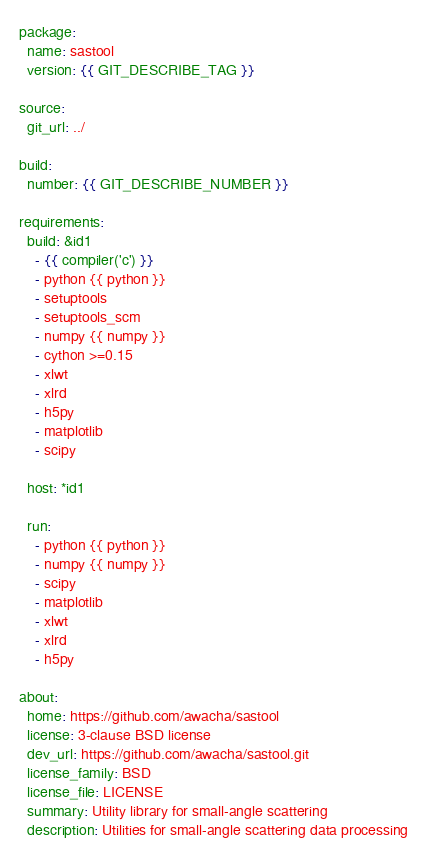<code> <loc_0><loc_0><loc_500><loc_500><_YAML_>package:
  name: sastool
  version: {{ GIT_DESCRIBE_TAG }}

source:
  git_url: ../

build:
  number: {{ GIT_DESCRIBE_NUMBER }}

requirements:
  build: &id1
    - {{ compiler('c') }}
    - python {{ python }}
    - setuptools
    - setuptools_scm
    - numpy {{ numpy }}
    - cython >=0.15
    - xlwt
    - xlrd
    - h5py
    - matplotlib
    - scipy
  
  host: *id1

  run:
    - python {{ python }}
    - numpy {{ numpy }}
    - scipy
    - matplotlib
    - xlwt
    - xlrd
    - h5py

about:
  home: https://github.com/awacha/sastool
  license: 3-clause BSD license
  dev_url: https://github.com/awacha/sastool.git
  license_family: BSD
  license_file: LICENSE
  summary: Utility library for small-angle scattering
  description: Utilities for small-angle scattering data processing
</code> 